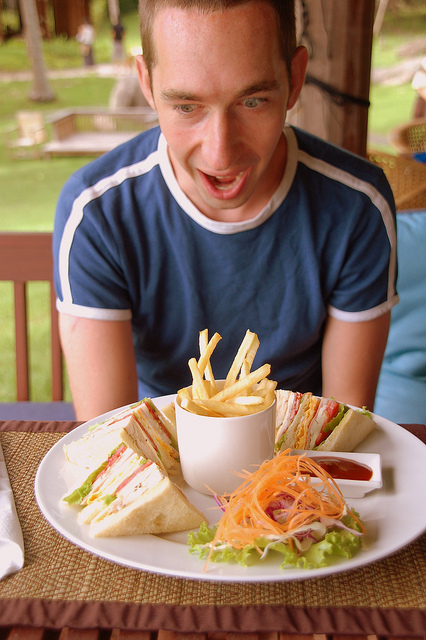<image>What kind of silverware is on his plate? There is no silverware on his plate. What kind of silverware is on his plate? I am not sure what kind of silverware is on his plate. It can be seen 'ceramic' or 'plastic'. 